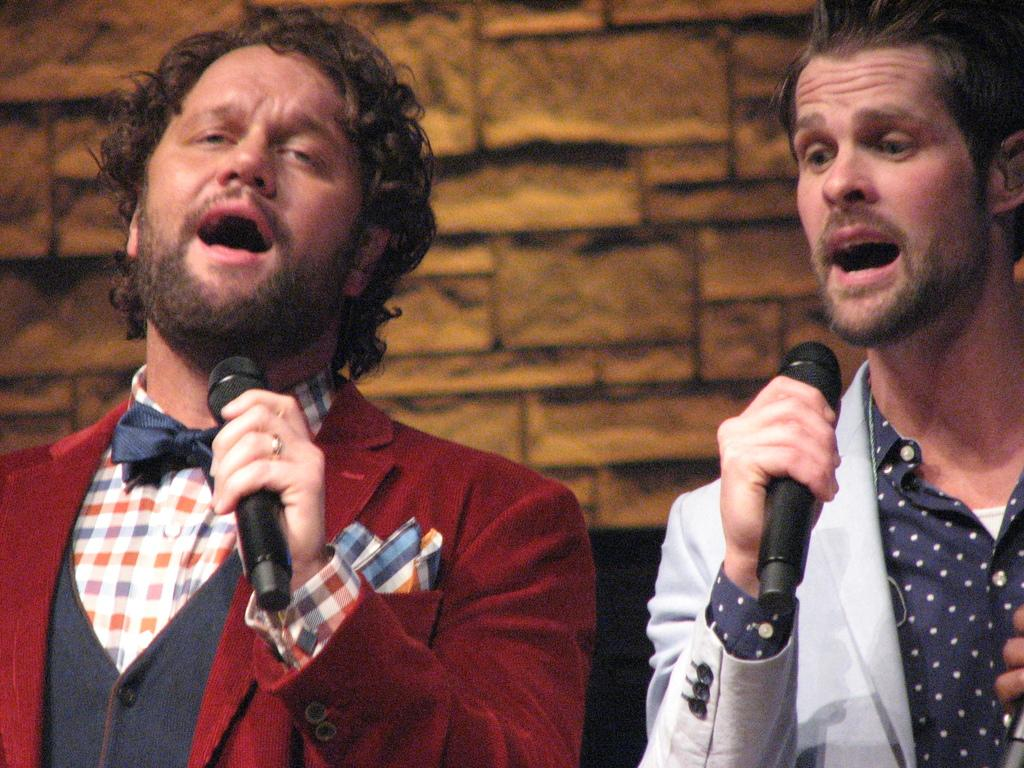How many people are in the image? There are two men in the image. What are the men doing in the image? The men are standing and singing. What objects are the men holding in the image? The men are holding black microphones. What can be seen in the background of the image? There is a yellow wall in the background of the image. How many cards are being used by the men in the image? There are no cards present in the image; the men are holding black microphones. Can you see any bikes in the image? There are no bikes visible in the image; the focus is on the two men singing with microphones. 